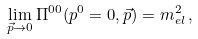Convert formula to latex. <formula><loc_0><loc_0><loc_500><loc_500>\lim _ { \vec { p } \rightarrow 0 } \Pi ^ { 0 0 } ( p ^ { 0 } = 0 , \vec { p } ) = m _ { e l } ^ { 2 } \, ,</formula> 